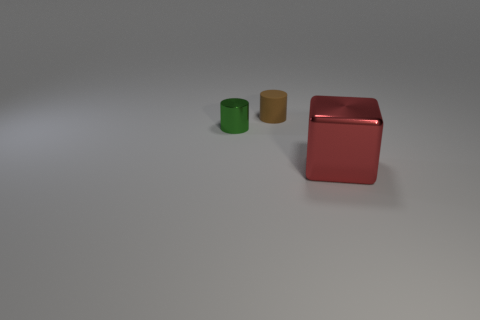Can you infer the possible function of these objects? Without additional context, it's challenging to determine the exact functions of these objects. They resemble containers or cylinders, which might suggest storage as their primary function. The green and yellow objects could be simpler containers or canisters, while the red object might be a larger storage box or case. 